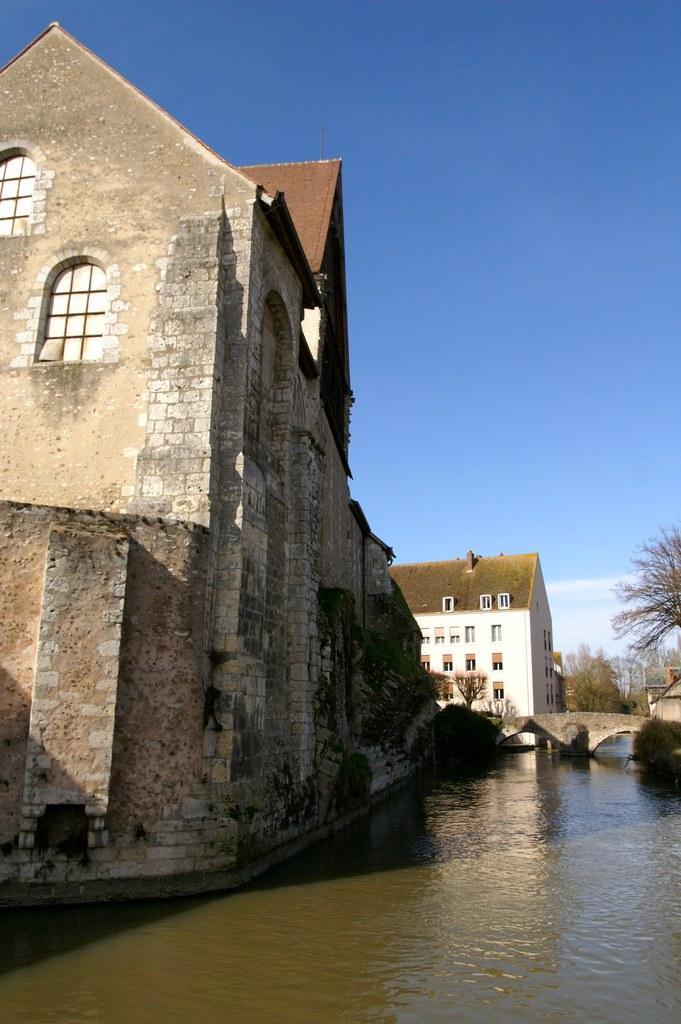Please provide a concise description of this image. In this image there are few buildings, trees, water and the sky. 